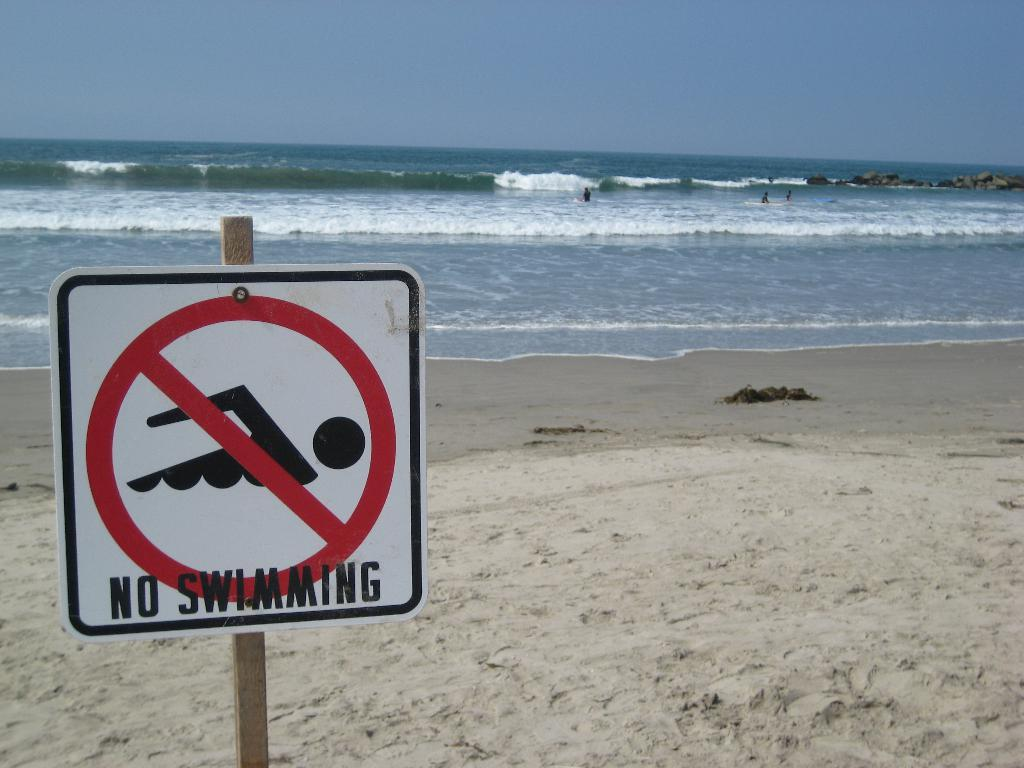<image>
Provide a brief description of the given image. A sign that no swimming is allowed is posted on the beach but there are people in the water. 